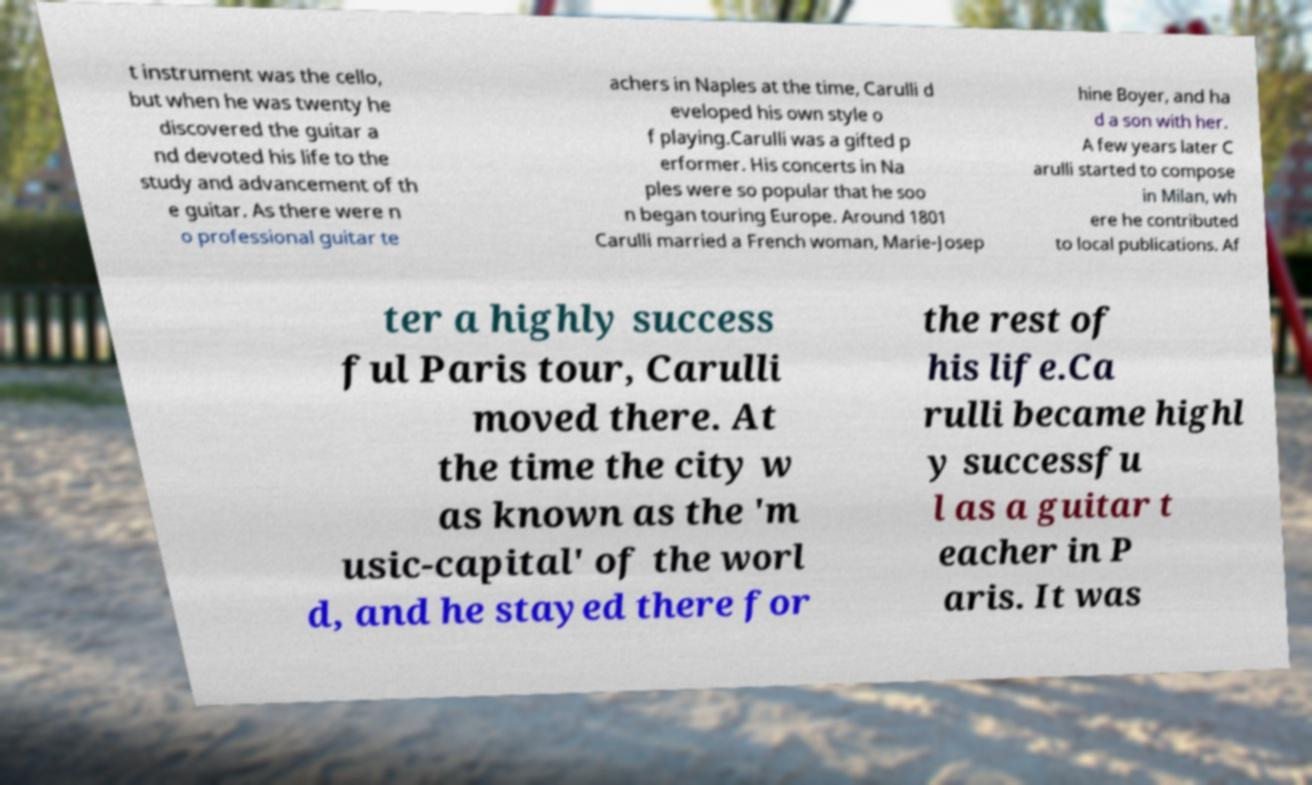What messages or text are displayed in this image? I need them in a readable, typed format. t instrument was the cello, but when he was twenty he discovered the guitar a nd devoted his life to the study and advancement of th e guitar. As there were n o professional guitar te achers in Naples at the time, Carulli d eveloped his own style o f playing.Carulli was a gifted p erformer. His concerts in Na ples were so popular that he soo n began touring Europe. Around 1801 Carulli married a French woman, Marie-Josep hine Boyer, and ha d a son with her. A few years later C arulli started to compose in Milan, wh ere he contributed to local publications. Af ter a highly success ful Paris tour, Carulli moved there. At the time the city w as known as the 'm usic-capital' of the worl d, and he stayed there for the rest of his life.Ca rulli became highl y successfu l as a guitar t eacher in P aris. It was 